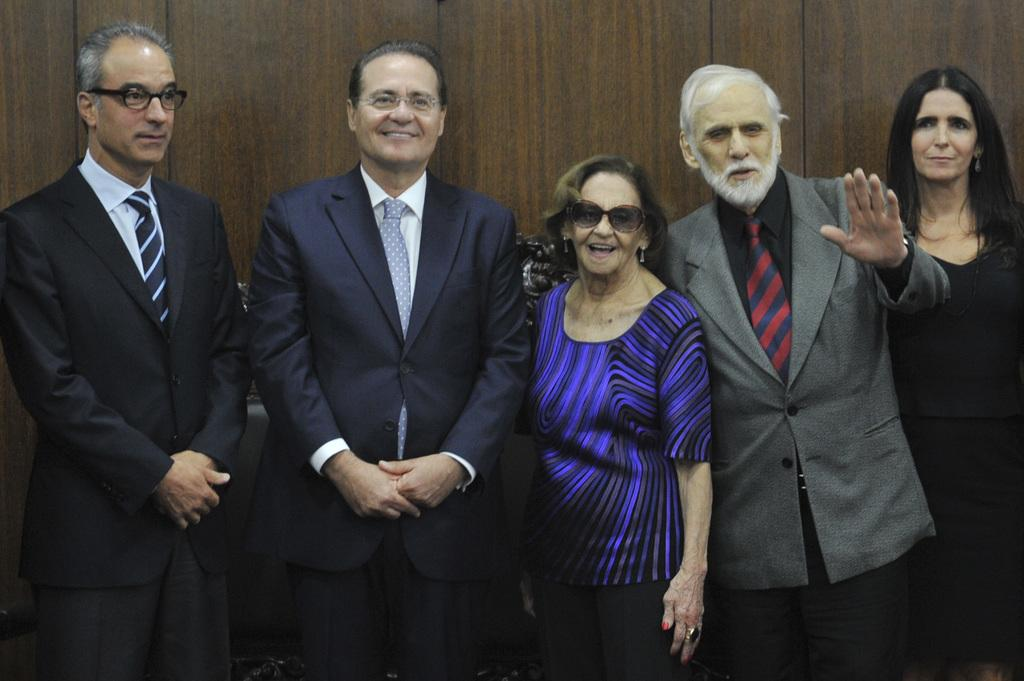How many people are in the image? There is a group of persons in the image. What are the persons in the image doing? The persons are standing and laughing. What can be seen in the background of the image? There is a wooden wall in the background of the image. Can you tell me how many horses are present in the image? There are no horses present in the image; it features a group of persons standing and laughing. What historical event is depicted in the image? There is no historical event depicted in the image; it shows a group of people standing and laughing. 